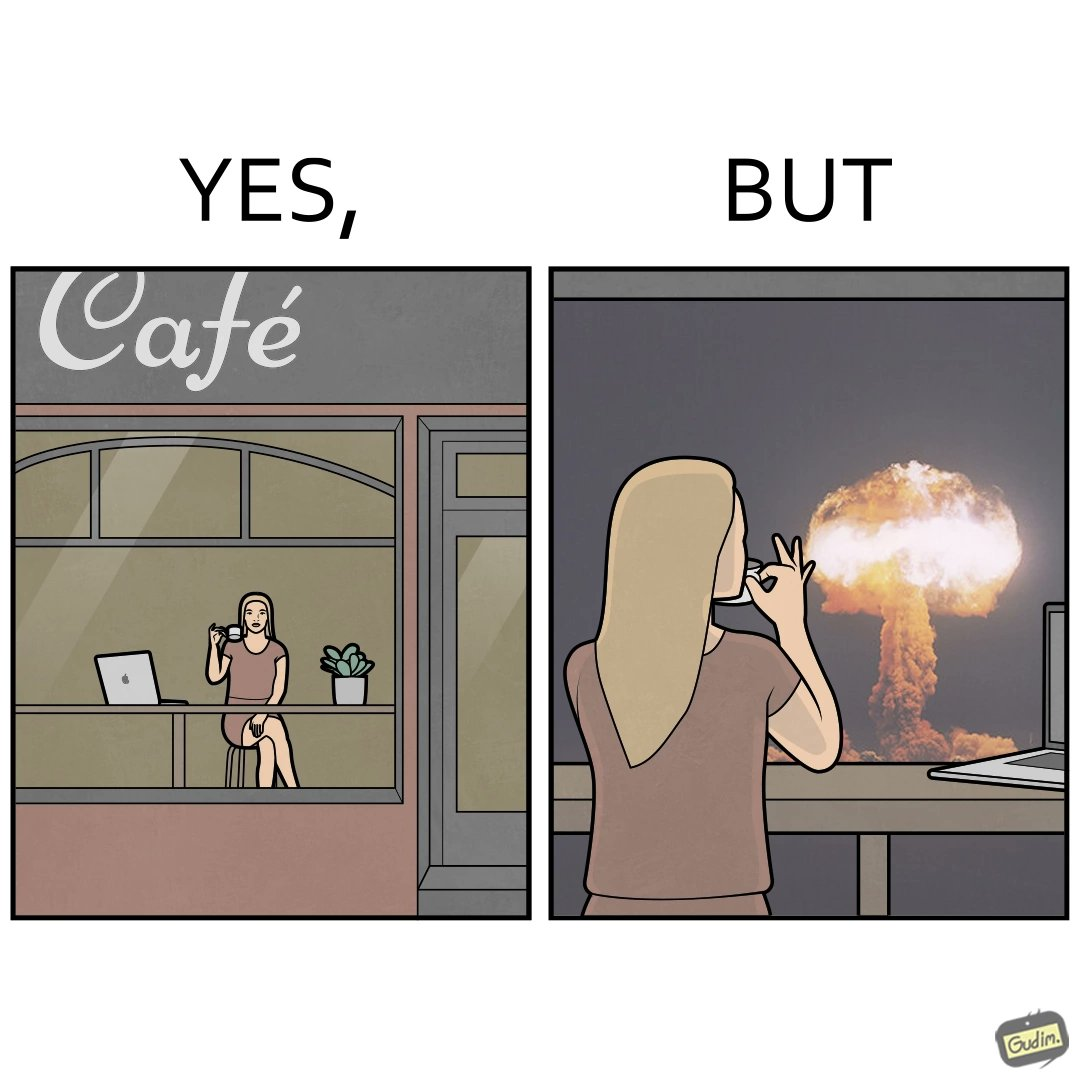Would you classify this image as satirical? Yes, this image is satirical. 